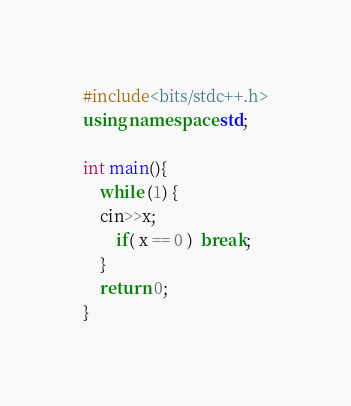<code> <loc_0><loc_0><loc_500><loc_500><_C++_>#include<bits/stdc++.h>
using namespace std;

int main(){
    while (1) {
	cin>>x;
        if( x == 0 )  break;
    }
    return 0;
}
</code> 